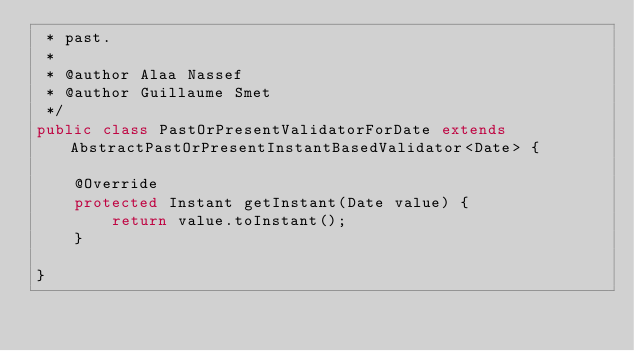Convert code to text. <code><loc_0><loc_0><loc_500><loc_500><_Java_> * past.
 *
 * @author Alaa Nassef
 * @author Guillaume Smet
 */
public class PastOrPresentValidatorForDate extends AbstractPastOrPresentInstantBasedValidator<Date> {

	@Override
	protected Instant getInstant(Date value) {
		return value.toInstant();
	}

}
</code> 